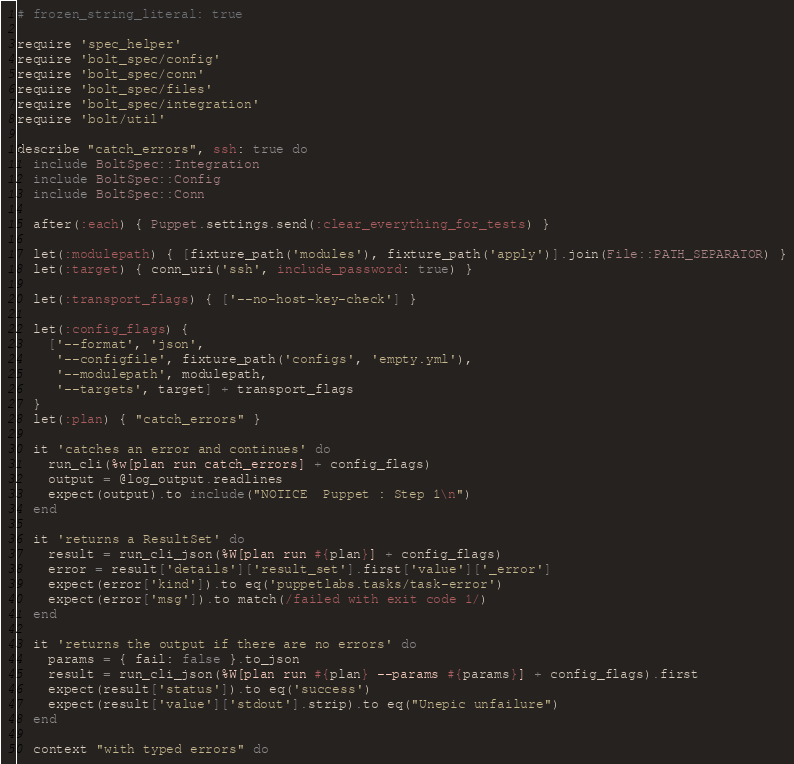<code> <loc_0><loc_0><loc_500><loc_500><_Ruby_># frozen_string_literal: true

require 'spec_helper'
require 'bolt_spec/config'
require 'bolt_spec/conn'
require 'bolt_spec/files'
require 'bolt_spec/integration'
require 'bolt/util'

describe "catch_errors", ssh: true do
  include BoltSpec::Integration
  include BoltSpec::Config
  include BoltSpec::Conn

  after(:each) { Puppet.settings.send(:clear_everything_for_tests) }

  let(:modulepath) { [fixture_path('modules'), fixture_path('apply')].join(File::PATH_SEPARATOR) }
  let(:target) { conn_uri('ssh', include_password: true) }

  let(:transport_flags) { ['--no-host-key-check'] }

  let(:config_flags) {
    ['--format', 'json',
     '--configfile', fixture_path('configs', 'empty.yml'),
     '--modulepath', modulepath,
     '--targets', target] + transport_flags
  }
  let(:plan) { "catch_errors" }

  it 'catches an error and continues' do
    run_cli(%w[plan run catch_errors] + config_flags)
    output = @log_output.readlines
    expect(output).to include("NOTICE  Puppet : Step 1\n")
  end

  it 'returns a ResultSet' do
    result = run_cli_json(%W[plan run #{plan}] + config_flags)
    error = result['details']['result_set'].first['value']['_error']
    expect(error['kind']).to eq('puppetlabs.tasks/task-error')
    expect(error['msg']).to match(/failed with exit code 1/)
  end

  it 'returns the output if there are no errors' do
    params = { fail: false }.to_json
    result = run_cli_json(%W[plan run #{plan} --params #{params}] + config_flags).first
    expect(result['status']).to eq('success')
    expect(result['value']['stdout'].strip).to eq("Unepic unfailure")
  end

  context "with typed errors" do</code> 